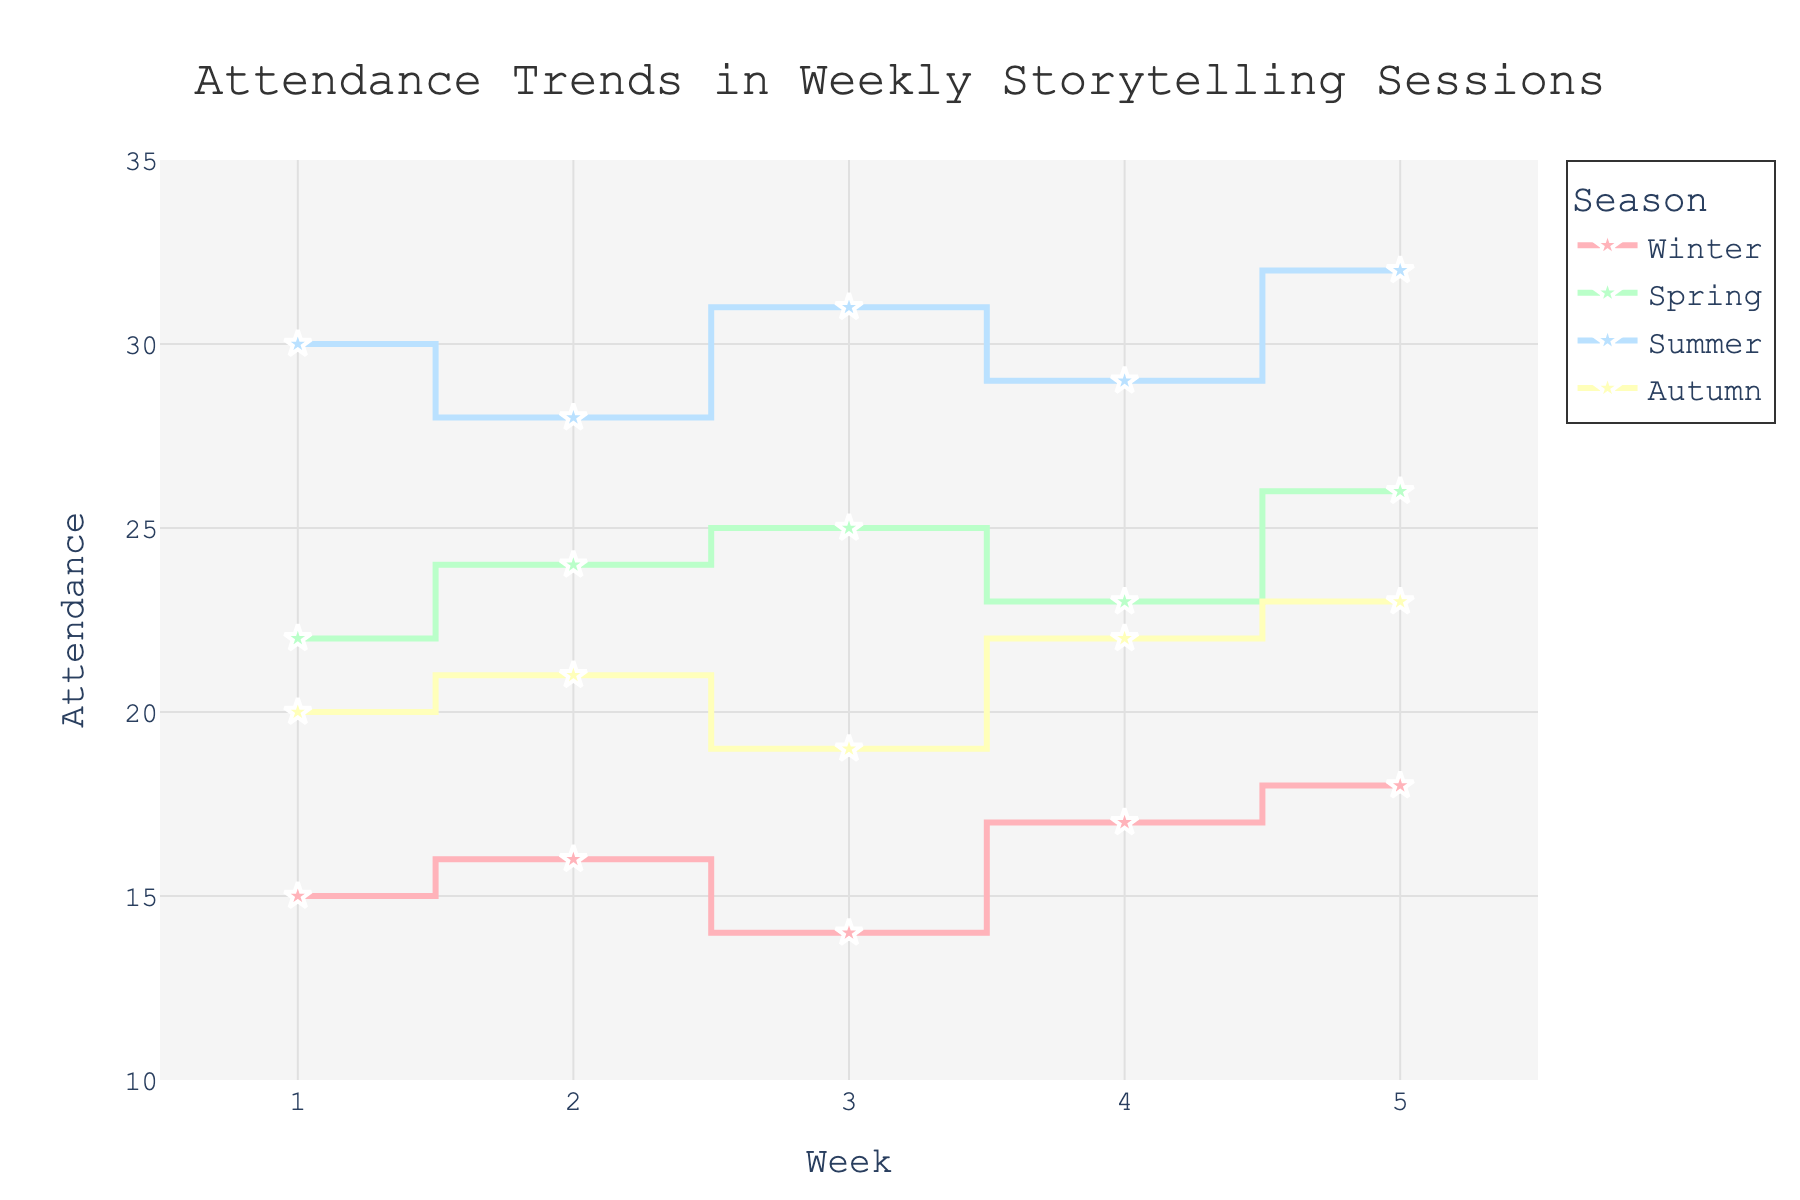What is the title of the plot? The title of the plot is displayed at the top and reads "Attendance Trends in Weekly Storytelling Sessions."
Answer: Attendance Trends in Weekly Storytelling Sessions What are the labels on the x-axis and y-axis? The x-axis label is "Week," and the y-axis label is "Attendance."
Answer: Week, Attendance How many marker symbols are used, and what shape are they? The plot uses star-shaped markers, as seen at each data point in the lines.
Answer: Star-shaped markers What is the average attendance for Summer? To find the average, sum up the attendance numbers for Summer (30 + 28 + 31 + 29 + 32 = 150) and divide by the number of data points, which is 5. So, 150 / 5 = 30.
Answer: 30 What is the total number of attendees in Spring and Autumn combined? Sum the weekly attendance for Spring (22 + 24 + 25 + 23 + 26 = 120) and for Autumn (20 + 21 + 19 + 22 + 23 = 105). Then, add these totals together: 120 + 105 = 225.
Answer: 225 Which season has the lowest starting attendance? Look at the first data point for each season and compare: Winter (15), Spring (22), Summer (30), and Autumn (20). Winter has the lowest starting attendance with 15.
Answer: Winter Which season has the highest peak attendance? Look for the highest data point in each season: Winter (18), Spring (26), Summer (32), and Autumn (23). Summer has the highest peak attendance with 32.
Answer: Summer How does the stair plot visually indicate weekly changes in attendance? The stair plot uses horizontal and vertical lines, where the horizontal part indicates the attendance for the week, and the vertical jump indicates the change to the next week's attendance.
Answer: Horizontal and vertical lines Which season shows the most consistent attendance across weeks? To determine consistency, look for the season with the smallest vertical jumps in the plot: Spring and Autumn show less dramatic changes, but Autumn has the smallest overall changes from week to week.
Answer: Autumn 